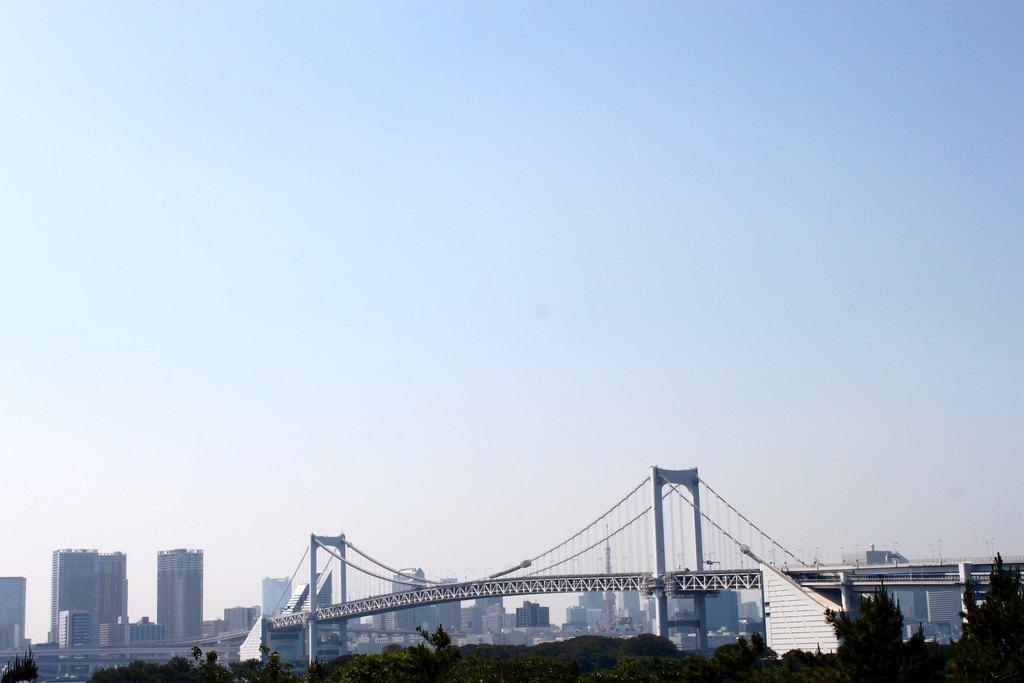What type of natural vegetation is present in the image? There are trees in the image. What type of structure can be seen crossing over a body of water? There is a bridge in the image. What body of water is visible in the image? There is a river in the image. What type of man-made structures can be seen in the image? There are buildings in the image. What part of the natural environment is visible in the image? The sky is visible in the image. What color crayon is being used to draw the bridge in the image? There is no crayon present in the image, and therefore no such activity can be observed. What type of spy equipment can be seen in the image? There is no spy equipment present in the image. What type of power source is visible in the image? There is no power source visible in the image. 